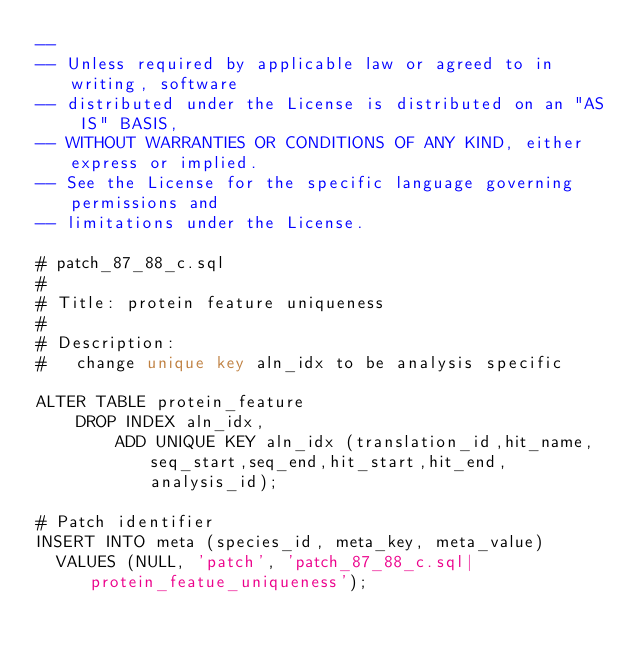Convert code to text. <code><loc_0><loc_0><loc_500><loc_500><_SQL_>-- 
-- Unless required by applicable law or agreed to in writing, software
-- distributed under the License is distributed on an "AS IS" BASIS,
-- WITHOUT WARRANTIES OR CONDITIONS OF ANY KIND, either express or implied.
-- See the License for the specific language governing permissions and
-- limitations under the License.

# patch_87_88_c.sql
#
# Title: protein feature uniqueness
#
# Description:
#   change unique key aln_idx to be analysis specific

ALTER TABLE protein_feature 
	DROP INDEX aln_idx,
        ADD UNIQUE KEY aln_idx (translation_id,hit_name,seq_start,seq_end,hit_start,hit_end,analysis_id);

# Patch identifier
INSERT INTO meta (species_id, meta_key, meta_value)
  VALUES (NULL, 'patch', 'patch_87_88_c.sql|protein_featue_uniqueness');

</code> 